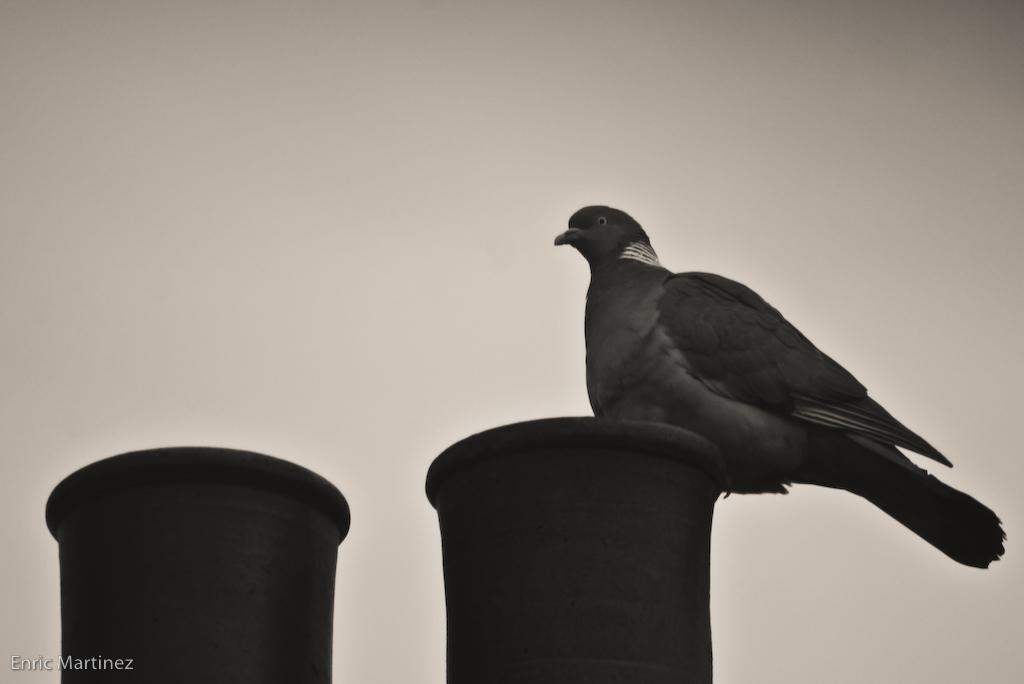What type of animal is in the image? There is a pigeon in the image. What is the pigeon sitting on? The pigeon is sitting on a black color object. What can be seen in the background of the image? There is a sky visible in the background of the image. How many sticks are being used by the pigeon in the image? There are no sticks present in the image; the pigeon is sitting on a black color object. 